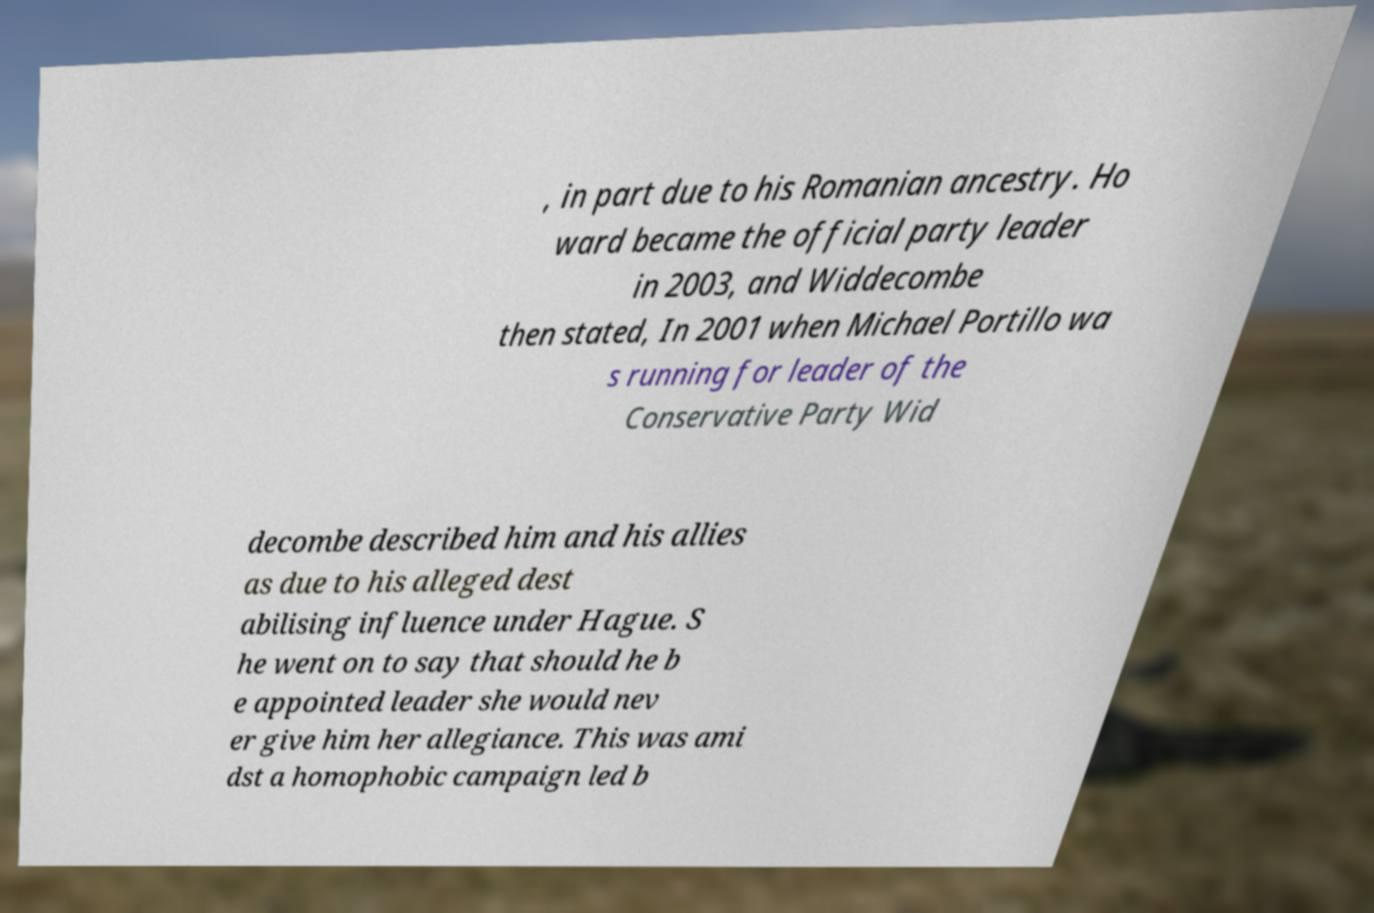Could you assist in decoding the text presented in this image and type it out clearly? , in part due to his Romanian ancestry. Ho ward became the official party leader in 2003, and Widdecombe then stated, In 2001 when Michael Portillo wa s running for leader of the Conservative Party Wid decombe described him and his allies as due to his alleged dest abilising influence under Hague. S he went on to say that should he b e appointed leader she would nev er give him her allegiance. This was ami dst a homophobic campaign led b 